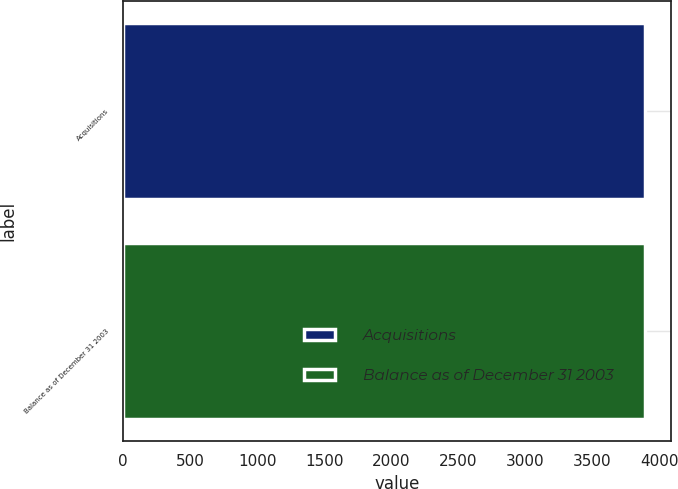Convert chart. <chart><loc_0><loc_0><loc_500><loc_500><bar_chart><fcel>Acquisitions<fcel>Balance as of December 31 2003<nl><fcel>3895<fcel>3895.1<nl></chart> 